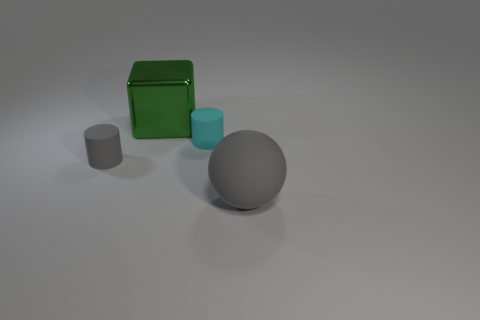Can you describe the shapes and colors of the objects in the image? Certainly! There are four objects in the image: a large gray sphere, a smaller cyan cylinder, a small gray cylinder, and a green rectangular box. The green box has a glossy surface, while the others appear to have matte finishes. 